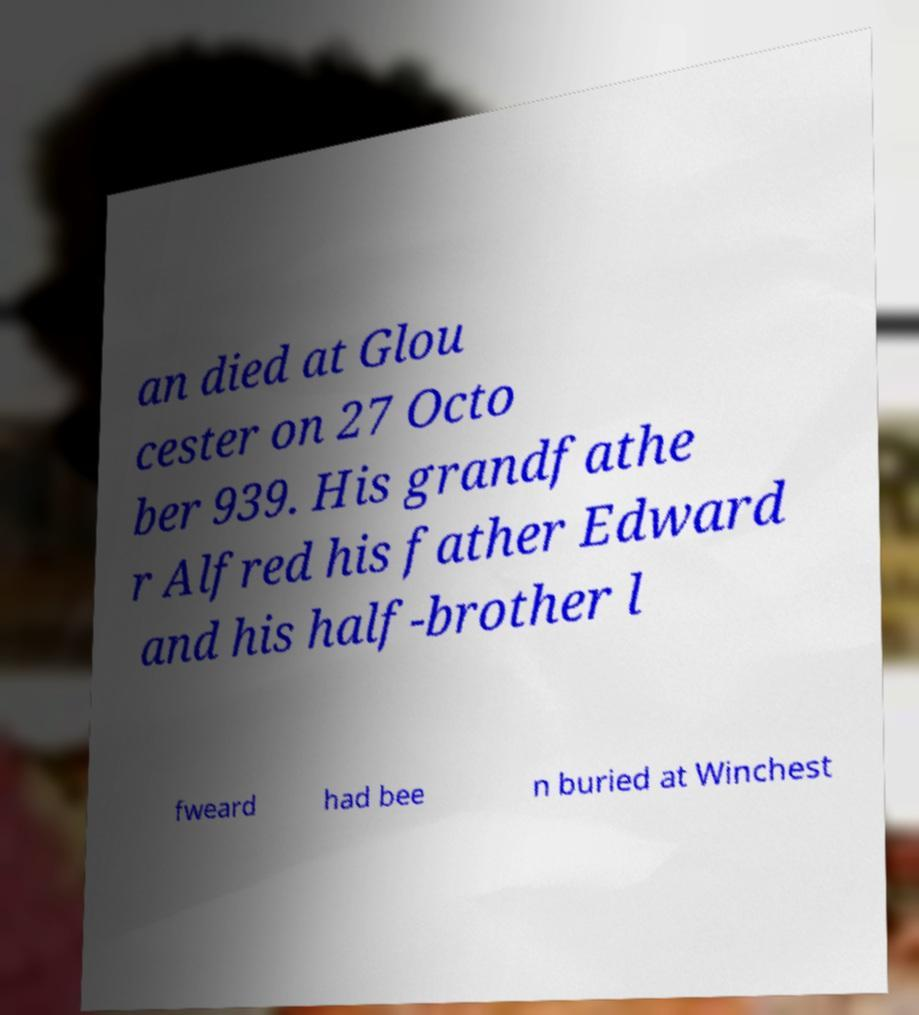Could you extract and type out the text from this image? an died at Glou cester on 27 Octo ber 939. His grandfathe r Alfred his father Edward and his half-brother l fweard had bee n buried at Winchest 